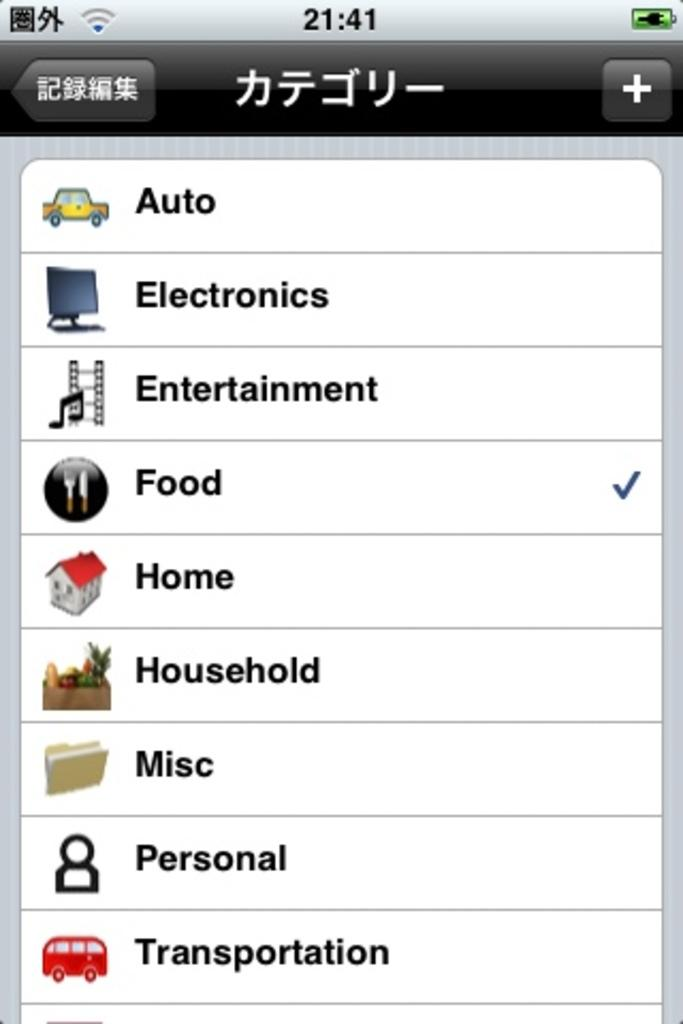Provide a one-sentence caption for the provided image. The screen has several options listed but only food is checked. 